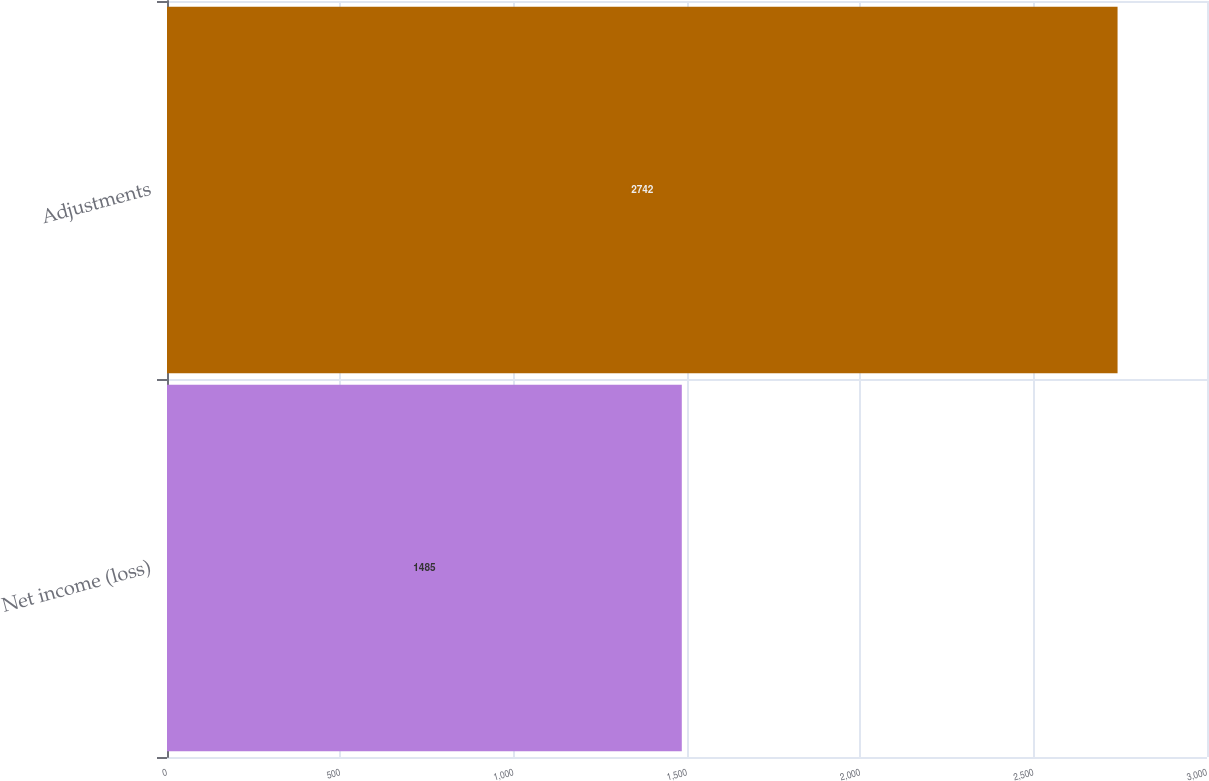Convert chart to OTSL. <chart><loc_0><loc_0><loc_500><loc_500><bar_chart><fcel>Net income (loss)<fcel>Adjustments<nl><fcel>1485<fcel>2742<nl></chart> 